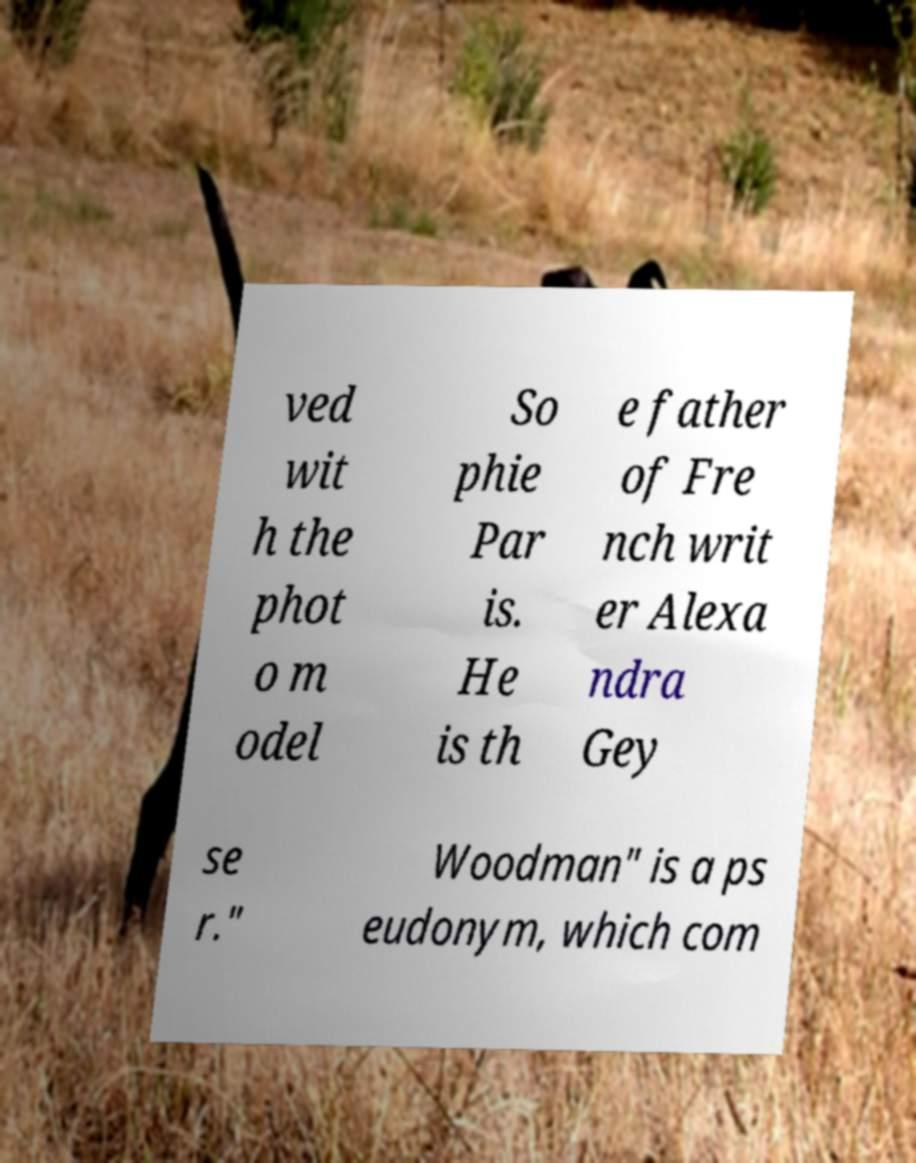I need the written content from this picture converted into text. Can you do that? ved wit h the phot o m odel So phie Par is. He is th e father of Fre nch writ er Alexa ndra Gey se r." Woodman" is a ps eudonym, which com 